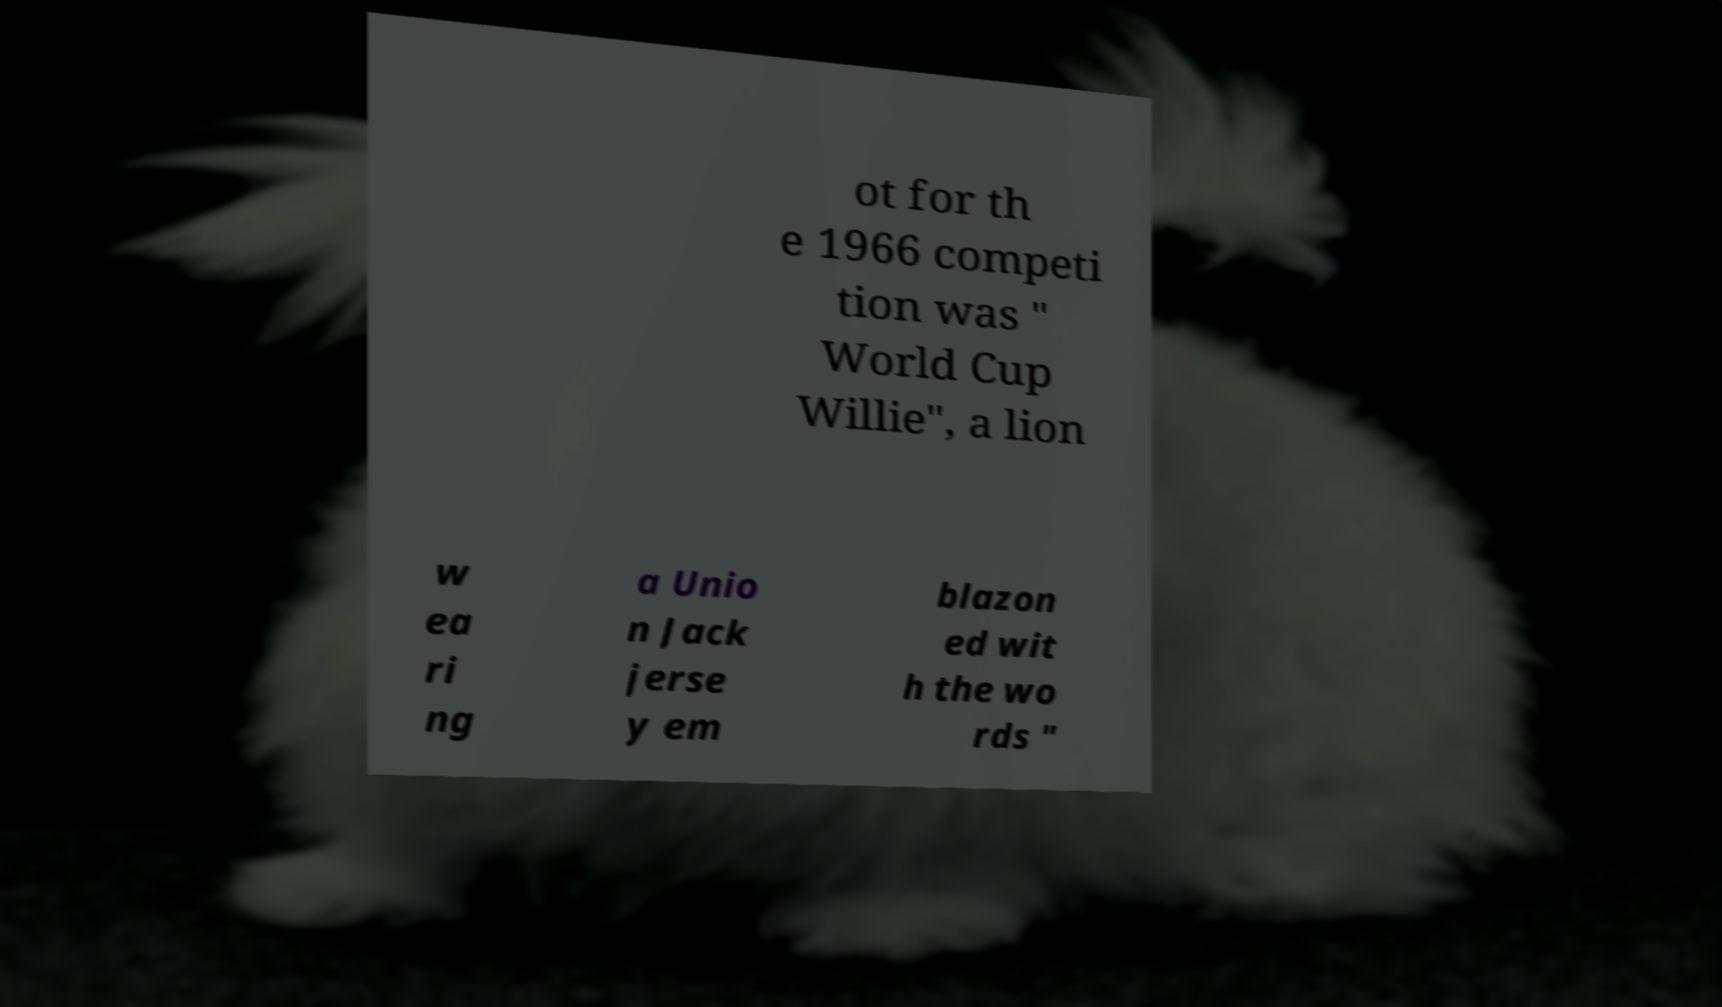Please identify and transcribe the text found in this image. ot for th e 1966 competi tion was " World Cup Willie", a lion w ea ri ng a Unio n Jack jerse y em blazon ed wit h the wo rds " 